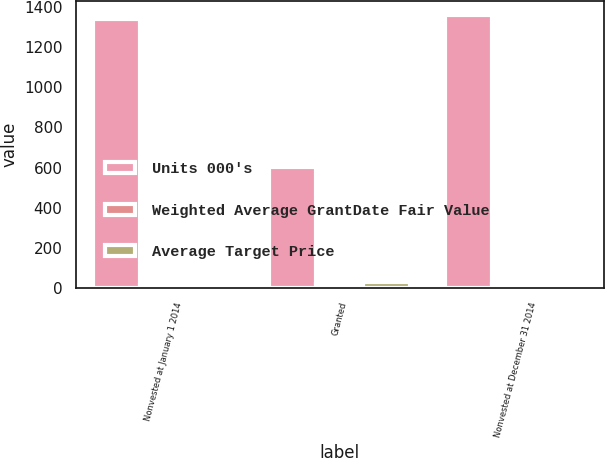Convert chart to OTSL. <chart><loc_0><loc_0><loc_500><loc_500><stacked_bar_chart><ecel><fcel>Nonvested at January 1 2014<fcel>Granted<fcel>Nonvested at December 31 2014<nl><fcel>Units 000's<fcel>1339<fcel>603<fcel>1358<nl><fcel>Weighted Average GrantDate Fair Value<fcel>13.85<fcel>22.51<fcel>18.27<nl><fcel>Average Target Price<fcel>16.95<fcel>29.8<fcel>20.48<nl></chart> 